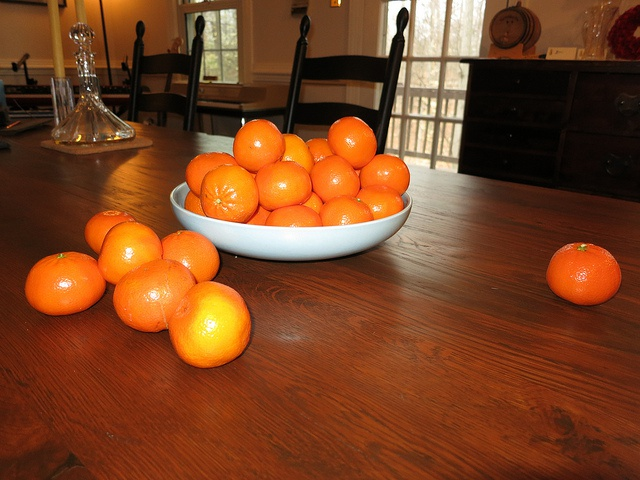Describe the objects in this image and their specific colors. I can see dining table in black, maroon, red, and brown tones, orange in black, red, and orange tones, chair in black, maroon, and red tones, bowl in black, white, darkgray, lightblue, and gray tones, and orange in black, orange, gold, red, and maroon tones in this image. 